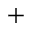<formula> <loc_0><loc_0><loc_500><loc_500>^ { + }</formula> 